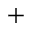<formula> <loc_0><loc_0><loc_500><loc_500>^ { + }</formula> 